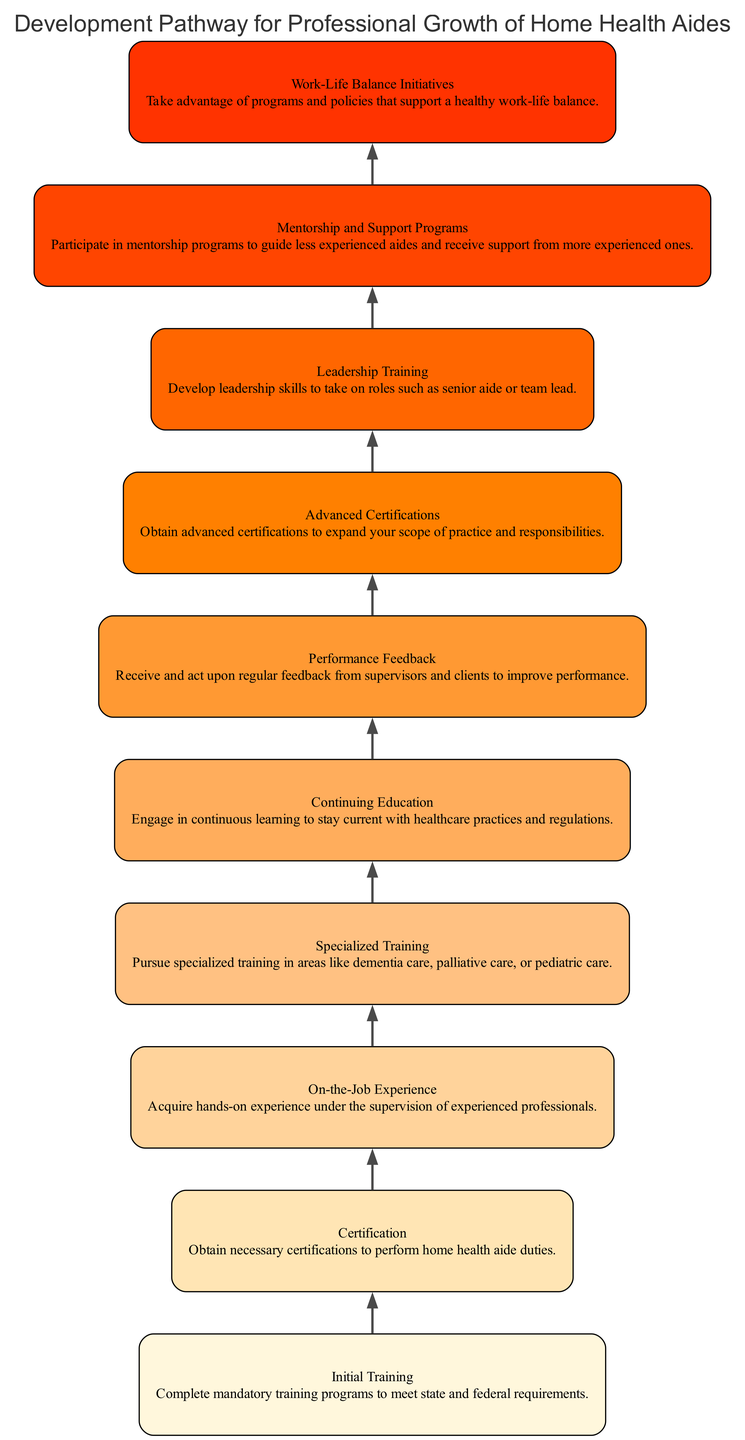What is the first step in the development pathway? The first step in the development pathway is identified by the node labeled as "1". This node states "Initial Training" clearly defined as the initial requirement for home health aides, thus making it the first step.
Answer: Initial Training How many steps are there in total? To find the total number of steps, we count each node in the diagram labeled from "1" to "10". There are ten nodes, which represent ten distinct steps in the pathway.
Answer: 10 What is the last step in the pathway? The last step is found at node "10" in the diagram, which is labeled "Work-Life Balance Initiatives". This represents the final part of the development pathway for home health aides.
Answer: Work-Life Balance Initiatives Which step involves obtaining certifications? Looking through the flow, step "2" is where the process of obtaining certifications takes place. It specifically mentions "Certification" as a requirement to perform duties.
Answer: Certification What type of training follows "On-the-Job Experience"? By analyzing the connections, "On-the-Job Experience" is node "3" and the following step or node "4" is "Specialized Training". Thus, Specialized Training is the next step in the process.
Answer: Specialized Training What does "Continuing Education" emphasize? The node labeled "5" clearly defines the purpose of Continuing Education, emphasizing ongoing learning for home health aides to remain updated with practices and regulations.
Answer: Continuous learning What kind of programs support less experienced aides? The node "9" specifically discusses "Mentorship and Support Programs," indicating that this step is aimed at supporting less experienced aides. This node illustrates the importance of mentorship within the pathway.
Answer: Mentorship and Support Programs Which node comes directly after "Advanced Certifications"? The node associated with "Advanced Certifications" is node "7", and it is followed directly by node "8" labeled as "Leadership Training". This sequential relationship facilitates understanding the workflow.
Answer: Leadership Training How many types of training does the diagram mention? By reviewing the nodes, training is categorized under "Initial Training", "Specialized Training", and "Leadership Training". This results in three distinct types of training within the diagram.
Answer: 3 